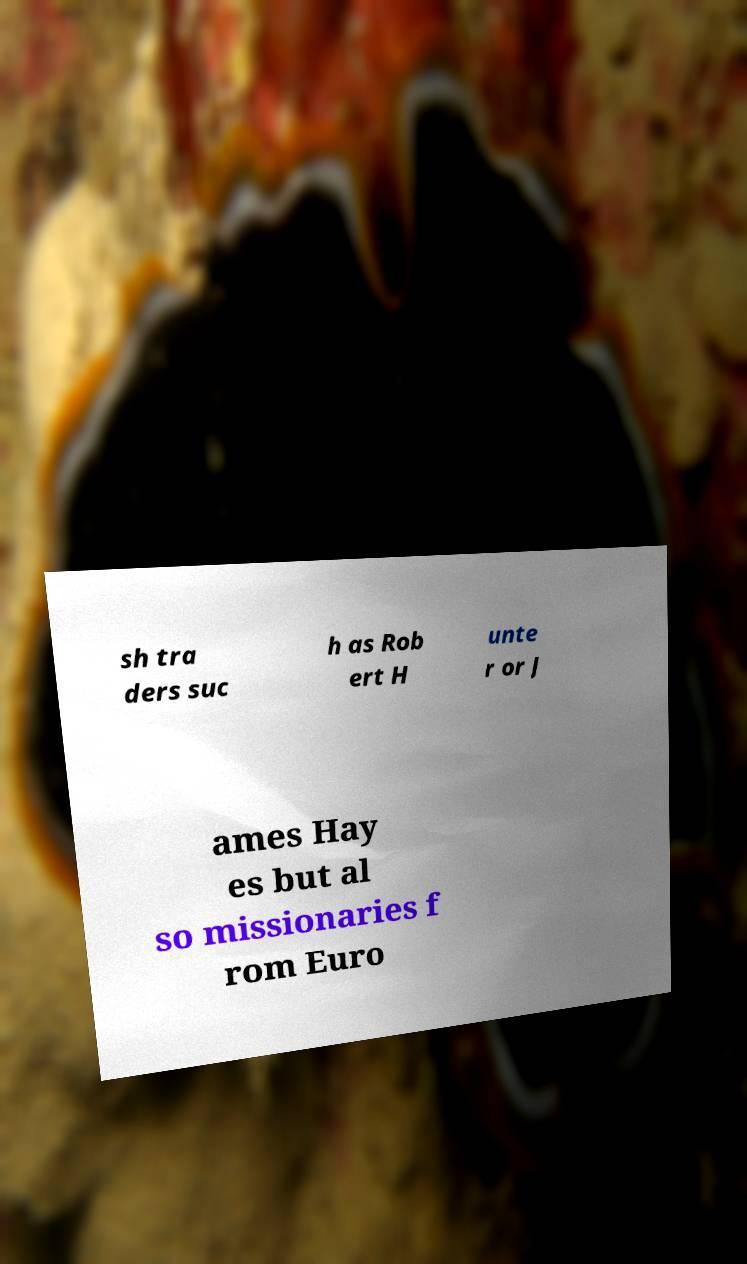There's text embedded in this image that I need extracted. Can you transcribe it verbatim? sh tra ders suc h as Rob ert H unte r or J ames Hay es but al so missionaries f rom Euro 